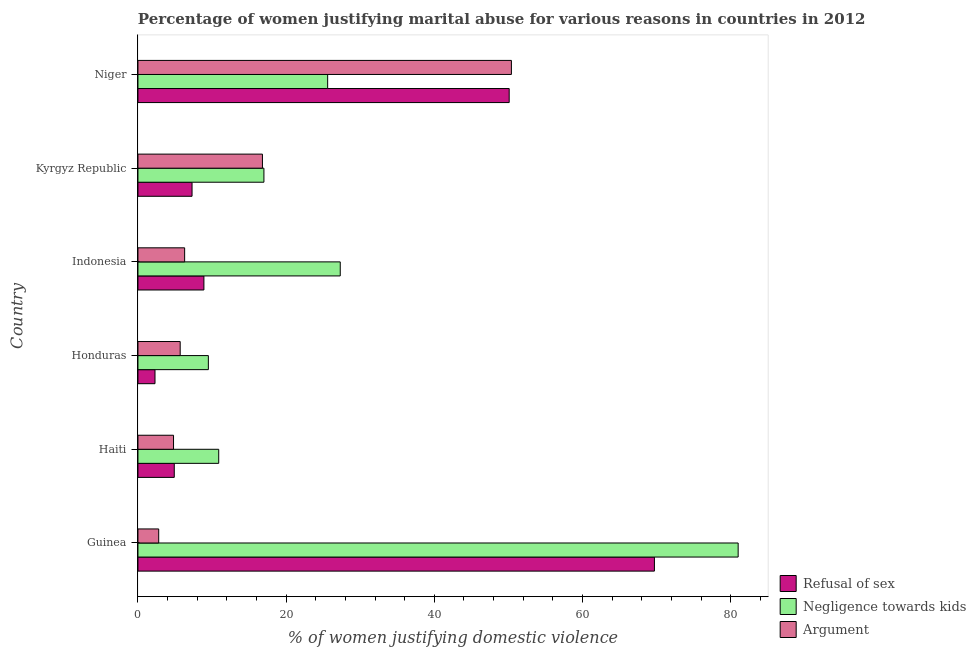Are the number of bars per tick equal to the number of legend labels?
Your response must be concise. Yes. What is the label of the 4th group of bars from the top?
Provide a succinct answer. Honduras. In how many cases, is the number of bars for a given country not equal to the number of legend labels?
Ensure brevity in your answer.  0. Across all countries, what is the maximum percentage of women justifying domestic violence due to refusal of sex?
Make the answer very short. 69.7. Across all countries, what is the minimum percentage of women justifying domestic violence due to negligence towards kids?
Offer a very short reply. 9.5. In which country was the percentage of women justifying domestic violence due to negligence towards kids maximum?
Offer a terse response. Guinea. In which country was the percentage of women justifying domestic violence due to arguments minimum?
Your response must be concise. Guinea. What is the total percentage of women justifying domestic violence due to negligence towards kids in the graph?
Provide a succinct answer. 171.3. What is the difference between the percentage of women justifying domestic violence due to refusal of sex in Indonesia and that in Kyrgyz Republic?
Offer a very short reply. 1.6. What is the difference between the percentage of women justifying domestic violence due to arguments in Honduras and the percentage of women justifying domestic violence due to negligence towards kids in Guinea?
Keep it short and to the point. -75.3. What is the average percentage of women justifying domestic violence due to arguments per country?
Give a very brief answer. 14.47. What is the difference between the percentage of women justifying domestic violence due to negligence towards kids and percentage of women justifying domestic violence due to arguments in Niger?
Your answer should be compact. -24.8. In how many countries, is the percentage of women justifying domestic violence due to arguments greater than 28 %?
Offer a terse response. 1. What is the ratio of the percentage of women justifying domestic violence due to arguments in Honduras to that in Niger?
Your answer should be compact. 0.11. Is the percentage of women justifying domestic violence due to arguments in Guinea less than that in Indonesia?
Your answer should be very brief. Yes. Is the difference between the percentage of women justifying domestic violence due to refusal of sex in Guinea and Indonesia greater than the difference between the percentage of women justifying domestic violence due to arguments in Guinea and Indonesia?
Make the answer very short. Yes. What is the difference between the highest and the second highest percentage of women justifying domestic violence due to arguments?
Give a very brief answer. 33.6. What is the difference between the highest and the lowest percentage of women justifying domestic violence due to negligence towards kids?
Provide a succinct answer. 71.5. Is the sum of the percentage of women justifying domestic violence due to negligence towards kids in Honduras and Niger greater than the maximum percentage of women justifying domestic violence due to arguments across all countries?
Offer a terse response. No. What does the 3rd bar from the top in Guinea represents?
Your response must be concise. Refusal of sex. What does the 2nd bar from the bottom in Niger represents?
Ensure brevity in your answer.  Negligence towards kids. How many countries are there in the graph?
Ensure brevity in your answer.  6. Does the graph contain any zero values?
Your response must be concise. No. Does the graph contain grids?
Ensure brevity in your answer.  No. What is the title of the graph?
Offer a terse response. Percentage of women justifying marital abuse for various reasons in countries in 2012. What is the label or title of the X-axis?
Make the answer very short. % of women justifying domestic violence. What is the label or title of the Y-axis?
Make the answer very short. Country. What is the % of women justifying domestic violence in Refusal of sex in Guinea?
Give a very brief answer. 69.7. What is the % of women justifying domestic violence of Refusal of sex in Haiti?
Offer a terse response. 4.9. What is the % of women justifying domestic violence in Negligence towards kids in Haiti?
Make the answer very short. 10.9. What is the % of women justifying domestic violence of Refusal of sex in Honduras?
Offer a terse response. 2.3. What is the % of women justifying domestic violence in Refusal of sex in Indonesia?
Ensure brevity in your answer.  8.9. What is the % of women justifying domestic violence in Negligence towards kids in Indonesia?
Keep it short and to the point. 27.3. What is the % of women justifying domestic violence in Refusal of sex in Kyrgyz Republic?
Provide a succinct answer. 7.3. What is the % of women justifying domestic violence of Refusal of sex in Niger?
Keep it short and to the point. 50.1. What is the % of women justifying domestic violence in Negligence towards kids in Niger?
Offer a very short reply. 25.6. What is the % of women justifying domestic violence of Argument in Niger?
Ensure brevity in your answer.  50.4. Across all countries, what is the maximum % of women justifying domestic violence of Refusal of sex?
Make the answer very short. 69.7. Across all countries, what is the maximum % of women justifying domestic violence in Negligence towards kids?
Offer a very short reply. 81. Across all countries, what is the maximum % of women justifying domestic violence in Argument?
Keep it short and to the point. 50.4. What is the total % of women justifying domestic violence in Refusal of sex in the graph?
Ensure brevity in your answer.  143.2. What is the total % of women justifying domestic violence in Negligence towards kids in the graph?
Your response must be concise. 171.3. What is the total % of women justifying domestic violence in Argument in the graph?
Your response must be concise. 86.8. What is the difference between the % of women justifying domestic violence of Refusal of sex in Guinea and that in Haiti?
Offer a very short reply. 64.8. What is the difference between the % of women justifying domestic violence of Negligence towards kids in Guinea and that in Haiti?
Your answer should be very brief. 70.1. What is the difference between the % of women justifying domestic violence in Argument in Guinea and that in Haiti?
Provide a succinct answer. -2. What is the difference between the % of women justifying domestic violence in Refusal of sex in Guinea and that in Honduras?
Offer a terse response. 67.4. What is the difference between the % of women justifying domestic violence in Negligence towards kids in Guinea and that in Honduras?
Provide a short and direct response. 71.5. What is the difference between the % of women justifying domestic violence of Refusal of sex in Guinea and that in Indonesia?
Offer a very short reply. 60.8. What is the difference between the % of women justifying domestic violence of Negligence towards kids in Guinea and that in Indonesia?
Provide a succinct answer. 53.7. What is the difference between the % of women justifying domestic violence of Argument in Guinea and that in Indonesia?
Ensure brevity in your answer.  -3.5. What is the difference between the % of women justifying domestic violence of Refusal of sex in Guinea and that in Kyrgyz Republic?
Keep it short and to the point. 62.4. What is the difference between the % of women justifying domestic violence of Negligence towards kids in Guinea and that in Kyrgyz Republic?
Offer a terse response. 64. What is the difference between the % of women justifying domestic violence in Refusal of sex in Guinea and that in Niger?
Offer a terse response. 19.6. What is the difference between the % of women justifying domestic violence of Negligence towards kids in Guinea and that in Niger?
Your answer should be very brief. 55.4. What is the difference between the % of women justifying domestic violence in Argument in Guinea and that in Niger?
Ensure brevity in your answer.  -47.6. What is the difference between the % of women justifying domestic violence of Refusal of sex in Haiti and that in Honduras?
Your response must be concise. 2.6. What is the difference between the % of women justifying domestic violence of Argument in Haiti and that in Honduras?
Offer a terse response. -0.9. What is the difference between the % of women justifying domestic violence of Negligence towards kids in Haiti and that in Indonesia?
Offer a terse response. -16.4. What is the difference between the % of women justifying domestic violence in Negligence towards kids in Haiti and that in Kyrgyz Republic?
Offer a very short reply. -6.1. What is the difference between the % of women justifying domestic violence of Refusal of sex in Haiti and that in Niger?
Make the answer very short. -45.2. What is the difference between the % of women justifying domestic violence of Negligence towards kids in Haiti and that in Niger?
Keep it short and to the point. -14.7. What is the difference between the % of women justifying domestic violence of Argument in Haiti and that in Niger?
Provide a short and direct response. -45.6. What is the difference between the % of women justifying domestic violence of Negligence towards kids in Honduras and that in Indonesia?
Offer a terse response. -17.8. What is the difference between the % of women justifying domestic violence in Argument in Honduras and that in Indonesia?
Offer a terse response. -0.6. What is the difference between the % of women justifying domestic violence of Refusal of sex in Honduras and that in Kyrgyz Republic?
Your answer should be very brief. -5. What is the difference between the % of women justifying domestic violence in Argument in Honduras and that in Kyrgyz Republic?
Your answer should be compact. -11.1. What is the difference between the % of women justifying domestic violence of Refusal of sex in Honduras and that in Niger?
Your response must be concise. -47.8. What is the difference between the % of women justifying domestic violence in Negligence towards kids in Honduras and that in Niger?
Your answer should be very brief. -16.1. What is the difference between the % of women justifying domestic violence in Argument in Honduras and that in Niger?
Give a very brief answer. -44.7. What is the difference between the % of women justifying domestic violence in Negligence towards kids in Indonesia and that in Kyrgyz Republic?
Give a very brief answer. 10.3. What is the difference between the % of women justifying domestic violence in Argument in Indonesia and that in Kyrgyz Republic?
Give a very brief answer. -10.5. What is the difference between the % of women justifying domestic violence in Refusal of sex in Indonesia and that in Niger?
Keep it short and to the point. -41.2. What is the difference between the % of women justifying domestic violence in Negligence towards kids in Indonesia and that in Niger?
Your response must be concise. 1.7. What is the difference between the % of women justifying domestic violence of Argument in Indonesia and that in Niger?
Your answer should be very brief. -44.1. What is the difference between the % of women justifying domestic violence of Refusal of sex in Kyrgyz Republic and that in Niger?
Your answer should be very brief. -42.8. What is the difference between the % of women justifying domestic violence of Negligence towards kids in Kyrgyz Republic and that in Niger?
Your answer should be compact. -8.6. What is the difference between the % of women justifying domestic violence in Argument in Kyrgyz Republic and that in Niger?
Offer a terse response. -33.6. What is the difference between the % of women justifying domestic violence in Refusal of sex in Guinea and the % of women justifying domestic violence in Negligence towards kids in Haiti?
Keep it short and to the point. 58.8. What is the difference between the % of women justifying domestic violence of Refusal of sex in Guinea and the % of women justifying domestic violence of Argument in Haiti?
Your answer should be very brief. 64.9. What is the difference between the % of women justifying domestic violence in Negligence towards kids in Guinea and the % of women justifying domestic violence in Argument in Haiti?
Your answer should be compact. 76.2. What is the difference between the % of women justifying domestic violence in Refusal of sex in Guinea and the % of women justifying domestic violence in Negligence towards kids in Honduras?
Give a very brief answer. 60.2. What is the difference between the % of women justifying domestic violence of Negligence towards kids in Guinea and the % of women justifying domestic violence of Argument in Honduras?
Your answer should be compact. 75.3. What is the difference between the % of women justifying domestic violence in Refusal of sex in Guinea and the % of women justifying domestic violence in Negligence towards kids in Indonesia?
Your answer should be very brief. 42.4. What is the difference between the % of women justifying domestic violence of Refusal of sex in Guinea and the % of women justifying domestic violence of Argument in Indonesia?
Offer a very short reply. 63.4. What is the difference between the % of women justifying domestic violence in Negligence towards kids in Guinea and the % of women justifying domestic violence in Argument in Indonesia?
Offer a terse response. 74.7. What is the difference between the % of women justifying domestic violence of Refusal of sex in Guinea and the % of women justifying domestic violence of Negligence towards kids in Kyrgyz Republic?
Give a very brief answer. 52.7. What is the difference between the % of women justifying domestic violence of Refusal of sex in Guinea and the % of women justifying domestic violence of Argument in Kyrgyz Republic?
Your response must be concise. 52.9. What is the difference between the % of women justifying domestic violence in Negligence towards kids in Guinea and the % of women justifying domestic violence in Argument in Kyrgyz Republic?
Provide a succinct answer. 64.2. What is the difference between the % of women justifying domestic violence of Refusal of sex in Guinea and the % of women justifying domestic violence of Negligence towards kids in Niger?
Provide a short and direct response. 44.1. What is the difference between the % of women justifying domestic violence in Refusal of sex in Guinea and the % of women justifying domestic violence in Argument in Niger?
Offer a very short reply. 19.3. What is the difference between the % of women justifying domestic violence in Negligence towards kids in Guinea and the % of women justifying domestic violence in Argument in Niger?
Your response must be concise. 30.6. What is the difference between the % of women justifying domestic violence in Refusal of sex in Haiti and the % of women justifying domestic violence in Negligence towards kids in Indonesia?
Offer a terse response. -22.4. What is the difference between the % of women justifying domestic violence in Refusal of sex in Haiti and the % of women justifying domestic violence in Argument in Indonesia?
Make the answer very short. -1.4. What is the difference between the % of women justifying domestic violence in Refusal of sex in Haiti and the % of women justifying domestic violence in Negligence towards kids in Kyrgyz Republic?
Make the answer very short. -12.1. What is the difference between the % of women justifying domestic violence of Refusal of sex in Haiti and the % of women justifying domestic violence of Argument in Kyrgyz Republic?
Provide a succinct answer. -11.9. What is the difference between the % of women justifying domestic violence of Negligence towards kids in Haiti and the % of women justifying domestic violence of Argument in Kyrgyz Republic?
Make the answer very short. -5.9. What is the difference between the % of women justifying domestic violence of Refusal of sex in Haiti and the % of women justifying domestic violence of Negligence towards kids in Niger?
Ensure brevity in your answer.  -20.7. What is the difference between the % of women justifying domestic violence of Refusal of sex in Haiti and the % of women justifying domestic violence of Argument in Niger?
Keep it short and to the point. -45.5. What is the difference between the % of women justifying domestic violence in Negligence towards kids in Haiti and the % of women justifying domestic violence in Argument in Niger?
Offer a terse response. -39.5. What is the difference between the % of women justifying domestic violence in Refusal of sex in Honduras and the % of women justifying domestic violence in Negligence towards kids in Kyrgyz Republic?
Provide a succinct answer. -14.7. What is the difference between the % of women justifying domestic violence of Negligence towards kids in Honduras and the % of women justifying domestic violence of Argument in Kyrgyz Republic?
Offer a terse response. -7.3. What is the difference between the % of women justifying domestic violence of Refusal of sex in Honduras and the % of women justifying domestic violence of Negligence towards kids in Niger?
Your answer should be compact. -23.3. What is the difference between the % of women justifying domestic violence of Refusal of sex in Honduras and the % of women justifying domestic violence of Argument in Niger?
Ensure brevity in your answer.  -48.1. What is the difference between the % of women justifying domestic violence of Negligence towards kids in Honduras and the % of women justifying domestic violence of Argument in Niger?
Keep it short and to the point. -40.9. What is the difference between the % of women justifying domestic violence in Refusal of sex in Indonesia and the % of women justifying domestic violence in Negligence towards kids in Kyrgyz Republic?
Offer a terse response. -8.1. What is the difference between the % of women justifying domestic violence in Refusal of sex in Indonesia and the % of women justifying domestic violence in Negligence towards kids in Niger?
Give a very brief answer. -16.7. What is the difference between the % of women justifying domestic violence of Refusal of sex in Indonesia and the % of women justifying domestic violence of Argument in Niger?
Your response must be concise. -41.5. What is the difference between the % of women justifying domestic violence of Negligence towards kids in Indonesia and the % of women justifying domestic violence of Argument in Niger?
Provide a succinct answer. -23.1. What is the difference between the % of women justifying domestic violence in Refusal of sex in Kyrgyz Republic and the % of women justifying domestic violence in Negligence towards kids in Niger?
Give a very brief answer. -18.3. What is the difference between the % of women justifying domestic violence of Refusal of sex in Kyrgyz Republic and the % of women justifying domestic violence of Argument in Niger?
Offer a very short reply. -43.1. What is the difference between the % of women justifying domestic violence of Negligence towards kids in Kyrgyz Republic and the % of women justifying domestic violence of Argument in Niger?
Your response must be concise. -33.4. What is the average % of women justifying domestic violence in Refusal of sex per country?
Offer a very short reply. 23.87. What is the average % of women justifying domestic violence of Negligence towards kids per country?
Offer a terse response. 28.55. What is the average % of women justifying domestic violence in Argument per country?
Provide a succinct answer. 14.47. What is the difference between the % of women justifying domestic violence in Refusal of sex and % of women justifying domestic violence in Argument in Guinea?
Offer a very short reply. 66.9. What is the difference between the % of women justifying domestic violence in Negligence towards kids and % of women justifying domestic violence in Argument in Guinea?
Make the answer very short. 78.2. What is the difference between the % of women justifying domestic violence in Refusal of sex and % of women justifying domestic violence in Negligence towards kids in Haiti?
Offer a terse response. -6. What is the difference between the % of women justifying domestic violence in Negligence towards kids and % of women justifying domestic violence in Argument in Haiti?
Provide a succinct answer. 6.1. What is the difference between the % of women justifying domestic violence in Refusal of sex and % of women justifying domestic violence in Negligence towards kids in Honduras?
Make the answer very short. -7.2. What is the difference between the % of women justifying domestic violence of Negligence towards kids and % of women justifying domestic violence of Argument in Honduras?
Your answer should be compact. 3.8. What is the difference between the % of women justifying domestic violence of Refusal of sex and % of women justifying domestic violence of Negligence towards kids in Indonesia?
Make the answer very short. -18.4. What is the difference between the % of women justifying domestic violence in Negligence towards kids and % of women justifying domestic violence in Argument in Indonesia?
Ensure brevity in your answer.  21. What is the difference between the % of women justifying domestic violence in Negligence towards kids and % of women justifying domestic violence in Argument in Kyrgyz Republic?
Offer a terse response. 0.2. What is the difference between the % of women justifying domestic violence of Refusal of sex and % of women justifying domestic violence of Negligence towards kids in Niger?
Ensure brevity in your answer.  24.5. What is the difference between the % of women justifying domestic violence in Negligence towards kids and % of women justifying domestic violence in Argument in Niger?
Offer a terse response. -24.8. What is the ratio of the % of women justifying domestic violence in Refusal of sex in Guinea to that in Haiti?
Your response must be concise. 14.22. What is the ratio of the % of women justifying domestic violence of Negligence towards kids in Guinea to that in Haiti?
Ensure brevity in your answer.  7.43. What is the ratio of the % of women justifying domestic violence of Argument in Guinea to that in Haiti?
Ensure brevity in your answer.  0.58. What is the ratio of the % of women justifying domestic violence in Refusal of sex in Guinea to that in Honduras?
Provide a succinct answer. 30.3. What is the ratio of the % of women justifying domestic violence in Negligence towards kids in Guinea to that in Honduras?
Provide a short and direct response. 8.53. What is the ratio of the % of women justifying domestic violence in Argument in Guinea to that in Honduras?
Ensure brevity in your answer.  0.49. What is the ratio of the % of women justifying domestic violence in Refusal of sex in Guinea to that in Indonesia?
Offer a very short reply. 7.83. What is the ratio of the % of women justifying domestic violence of Negligence towards kids in Guinea to that in Indonesia?
Offer a terse response. 2.97. What is the ratio of the % of women justifying domestic violence of Argument in Guinea to that in Indonesia?
Give a very brief answer. 0.44. What is the ratio of the % of women justifying domestic violence in Refusal of sex in Guinea to that in Kyrgyz Republic?
Your answer should be compact. 9.55. What is the ratio of the % of women justifying domestic violence in Negligence towards kids in Guinea to that in Kyrgyz Republic?
Offer a very short reply. 4.76. What is the ratio of the % of women justifying domestic violence in Argument in Guinea to that in Kyrgyz Republic?
Your answer should be compact. 0.17. What is the ratio of the % of women justifying domestic violence in Refusal of sex in Guinea to that in Niger?
Your answer should be very brief. 1.39. What is the ratio of the % of women justifying domestic violence of Negligence towards kids in Guinea to that in Niger?
Make the answer very short. 3.16. What is the ratio of the % of women justifying domestic violence of Argument in Guinea to that in Niger?
Ensure brevity in your answer.  0.06. What is the ratio of the % of women justifying domestic violence in Refusal of sex in Haiti to that in Honduras?
Provide a succinct answer. 2.13. What is the ratio of the % of women justifying domestic violence in Negligence towards kids in Haiti to that in Honduras?
Provide a succinct answer. 1.15. What is the ratio of the % of women justifying domestic violence in Argument in Haiti to that in Honduras?
Give a very brief answer. 0.84. What is the ratio of the % of women justifying domestic violence of Refusal of sex in Haiti to that in Indonesia?
Make the answer very short. 0.55. What is the ratio of the % of women justifying domestic violence in Negligence towards kids in Haiti to that in Indonesia?
Provide a succinct answer. 0.4. What is the ratio of the % of women justifying domestic violence of Argument in Haiti to that in Indonesia?
Your response must be concise. 0.76. What is the ratio of the % of women justifying domestic violence of Refusal of sex in Haiti to that in Kyrgyz Republic?
Provide a succinct answer. 0.67. What is the ratio of the % of women justifying domestic violence of Negligence towards kids in Haiti to that in Kyrgyz Republic?
Your answer should be compact. 0.64. What is the ratio of the % of women justifying domestic violence in Argument in Haiti to that in Kyrgyz Republic?
Provide a succinct answer. 0.29. What is the ratio of the % of women justifying domestic violence in Refusal of sex in Haiti to that in Niger?
Give a very brief answer. 0.1. What is the ratio of the % of women justifying domestic violence in Negligence towards kids in Haiti to that in Niger?
Your answer should be very brief. 0.43. What is the ratio of the % of women justifying domestic violence in Argument in Haiti to that in Niger?
Offer a very short reply. 0.1. What is the ratio of the % of women justifying domestic violence in Refusal of sex in Honduras to that in Indonesia?
Offer a very short reply. 0.26. What is the ratio of the % of women justifying domestic violence of Negligence towards kids in Honduras to that in Indonesia?
Offer a terse response. 0.35. What is the ratio of the % of women justifying domestic violence of Argument in Honduras to that in Indonesia?
Your answer should be compact. 0.9. What is the ratio of the % of women justifying domestic violence in Refusal of sex in Honduras to that in Kyrgyz Republic?
Your answer should be very brief. 0.32. What is the ratio of the % of women justifying domestic violence in Negligence towards kids in Honduras to that in Kyrgyz Republic?
Your answer should be compact. 0.56. What is the ratio of the % of women justifying domestic violence in Argument in Honduras to that in Kyrgyz Republic?
Make the answer very short. 0.34. What is the ratio of the % of women justifying domestic violence of Refusal of sex in Honduras to that in Niger?
Provide a short and direct response. 0.05. What is the ratio of the % of women justifying domestic violence of Negligence towards kids in Honduras to that in Niger?
Your response must be concise. 0.37. What is the ratio of the % of women justifying domestic violence in Argument in Honduras to that in Niger?
Make the answer very short. 0.11. What is the ratio of the % of women justifying domestic violence in Refusal of sex in Indonesia to that in Kyrgyz Republic?
Offer a very short reply. 1.22. What is the ratio of the % of women justifying domestic violence of Negligence towards kids in Indonesia to that in Kyrgyz Republic?
Your response must be concise. 1.61. What is the ratio of the % of women justifying domestic violence of Argument in Indonesia to that in Kyrgyz Republic?
Ensure brevity in your answer.  0.38. What is the ratio of the % of women justifying domestic violence in Refusal of sex in Indonesia to that in Niger?
Make the answer very short. 0.18. What is the ratio of the % of women justifying domestic violence in Negligence towards kids in Indonesia to that in Niger?
Your answer should be very brief. 1.07. What is the ratio of the % of women justifying domestic violence of Refusal of sex in Kyrgyz Republic to that in Niger?
Provide a succinct answer. 0.15. What is the ratio of the % of women justifying domestic violence in Negligence towards kids in Kyrgyz Republic to that in Niger?
Keep it short and to the point. 0.66. What is the difference between the highest and the second highest % of women justifying domestic violence in Refusal of sex?
Give a very brief answer. 19.6. What is the difference between the highest and the second highest % of women justifying domestic violence in Negligence towards kids?
Make the answer very short. 53.7. What is the difference between the highest and the second highest % of women justifying domestic violence of Argument?
Make the answer very short. 33.6. What is the difference between the highest and the lowest % of women justifying domestic violence of Refusal of sex?
Ensure brevity in your answer.  67.4. What is the difference between the highest and the lowest % of women justifying domestic violence of Negligence towards kids?
Your answer should be very brief. 71.5. What is the difference between the highest and the lowest % of women justifying domestic violence of Argument?
Keep it short and to the point. 47.6. 